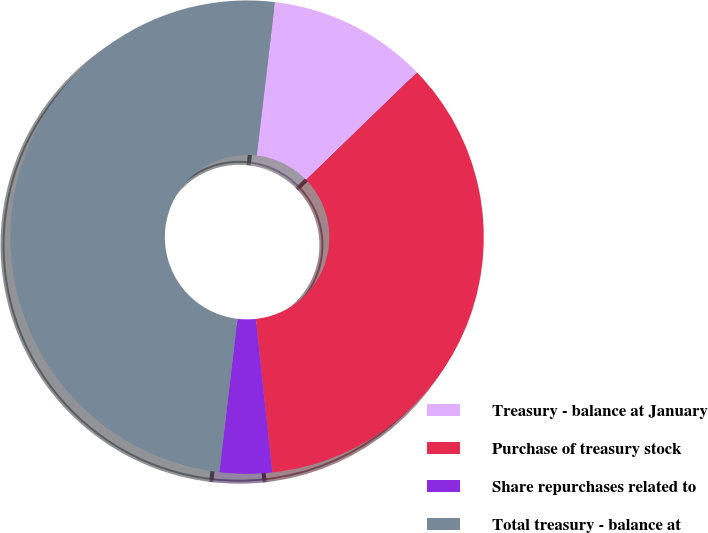Convert chart to OTSL. <chart><loc_0><loc_0><loc_500><loc_500><pie_chart><fcel>Treasury - balance at January<fcel>Purchase of treasury stock<fcel>Share repurchases related to<fcel>Total treasury - balance at<nl><fcel>10.87%<fcel>35.55%<fcel>3.57%<fcel>50.0%<nl></chart> 